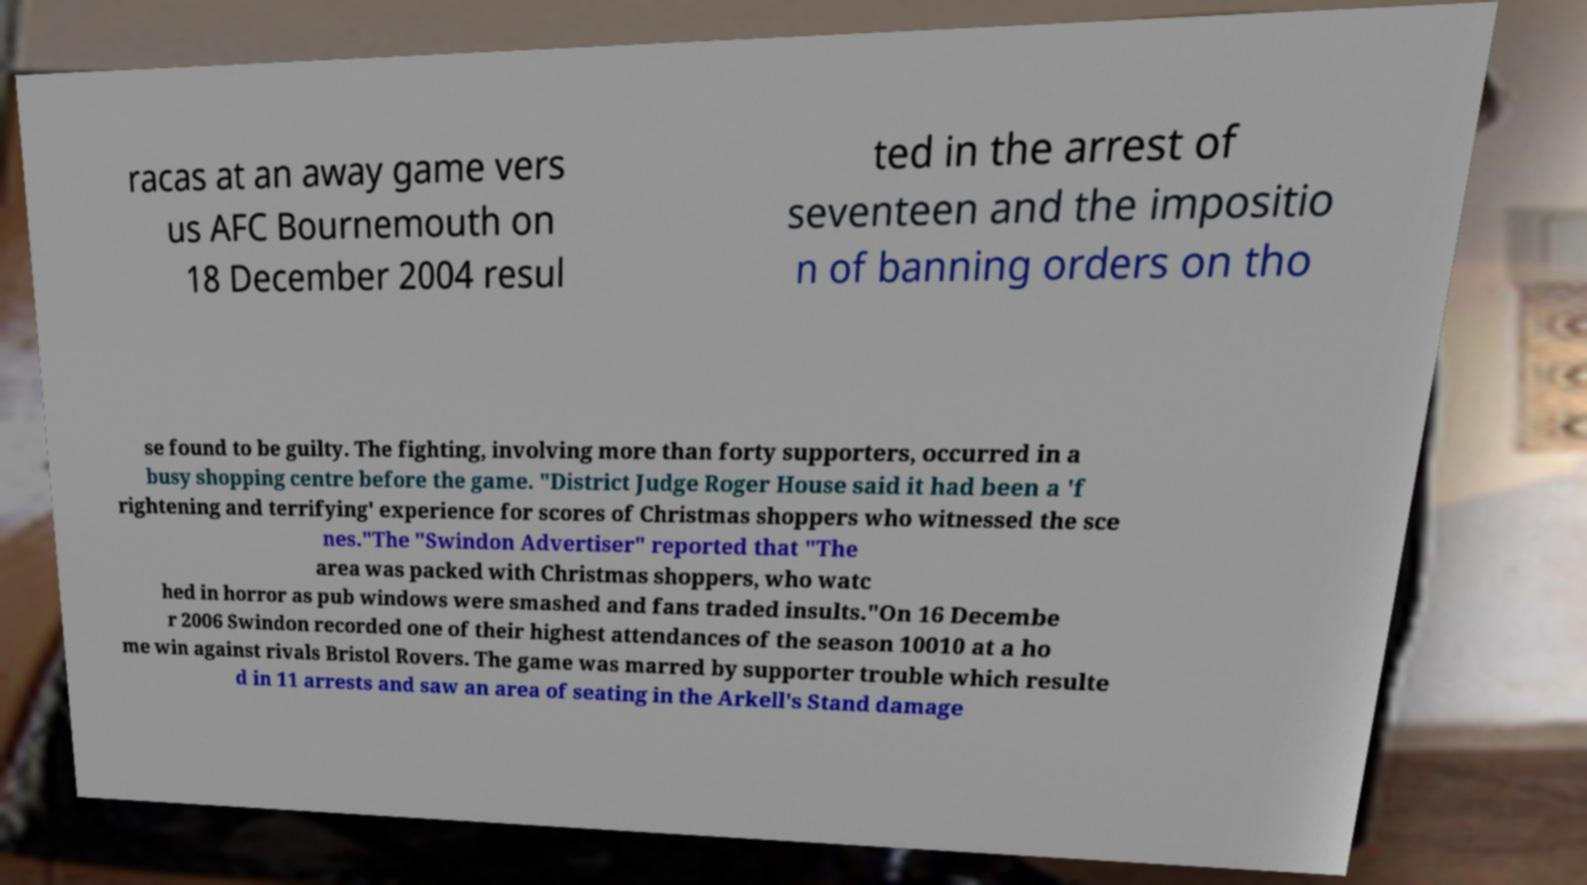There's text embedded in this image that I need extracted. Can you transcribe it verbatim? racas at an away game vers us AFC Bournemouth on 18 December 2004 resul ted in the arrest of seventeen and the impositio n of banning orders on tho se found to be guilty. The fighting, involving more than forty supporters, occurred in a busy shopping centre before the game. "District Judge Roger House said it had been a 'f rightening and terrifying' experience for scores of Christmas shoppers who witnessed the sce nes."The "Swindon Advertiser" reported that "The area was packed with Christmas shoppers, who watc hed in horror as pub windows were smashed and fans traded insults."On 16 Decembe r 2006 Swindon recorded one of their highest attendances of the season 10010 at a ho me win against rivals Bristol Rovers. The game was marred by supporter trouble which resulte d in 11 arrests and saw an area of seating in the Arkell's Stand damage 